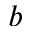<formula> <loc_0><loc_0><loc_500><loc_500>b</formula> 